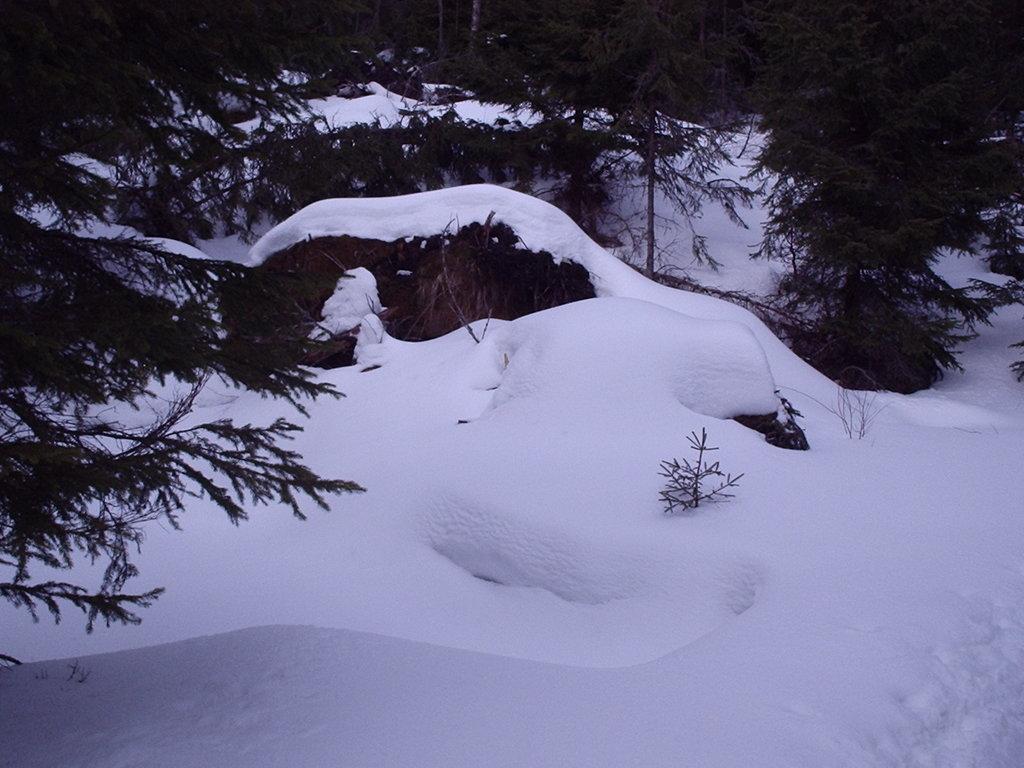Please provide a concise description of this image. Here we can see snow and trees are on the ground. 